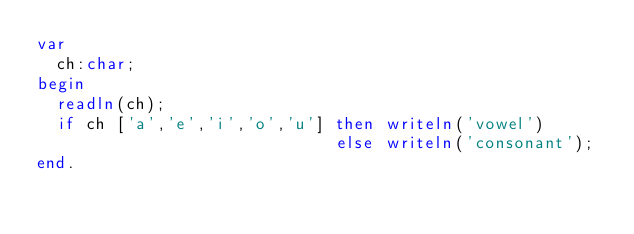<code> <loc_0><loc_0><loc_500><loc_500><_Pascal_>var
  ch:char;
begin
  readln(ch);
  if ch ['a','e','i','o','u'] then writeln('vowel')
                              else writeln('consonant');
end.</code> 